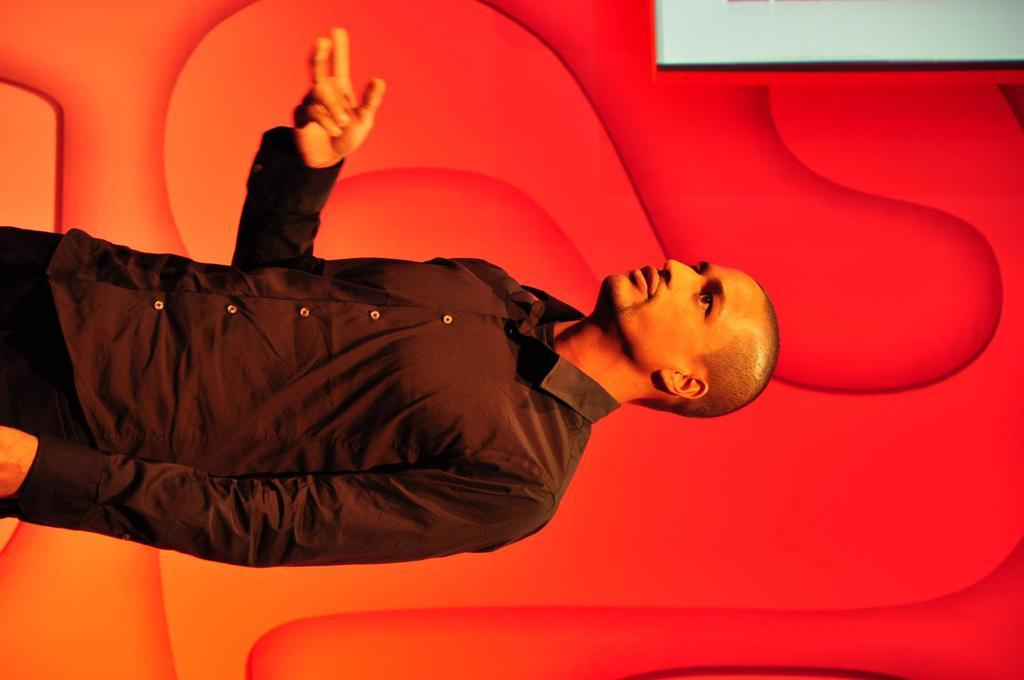What is the main subject of the image? There is a person in the image. Where is the person located in the image? The person is in the middle of the image. What color can be seen in the background of the image? There is a red color visible in the background of the image. What type of thread is being used by the goat in the image? There is no goat present in the image, and therefore no thread or related activity can be observed. 